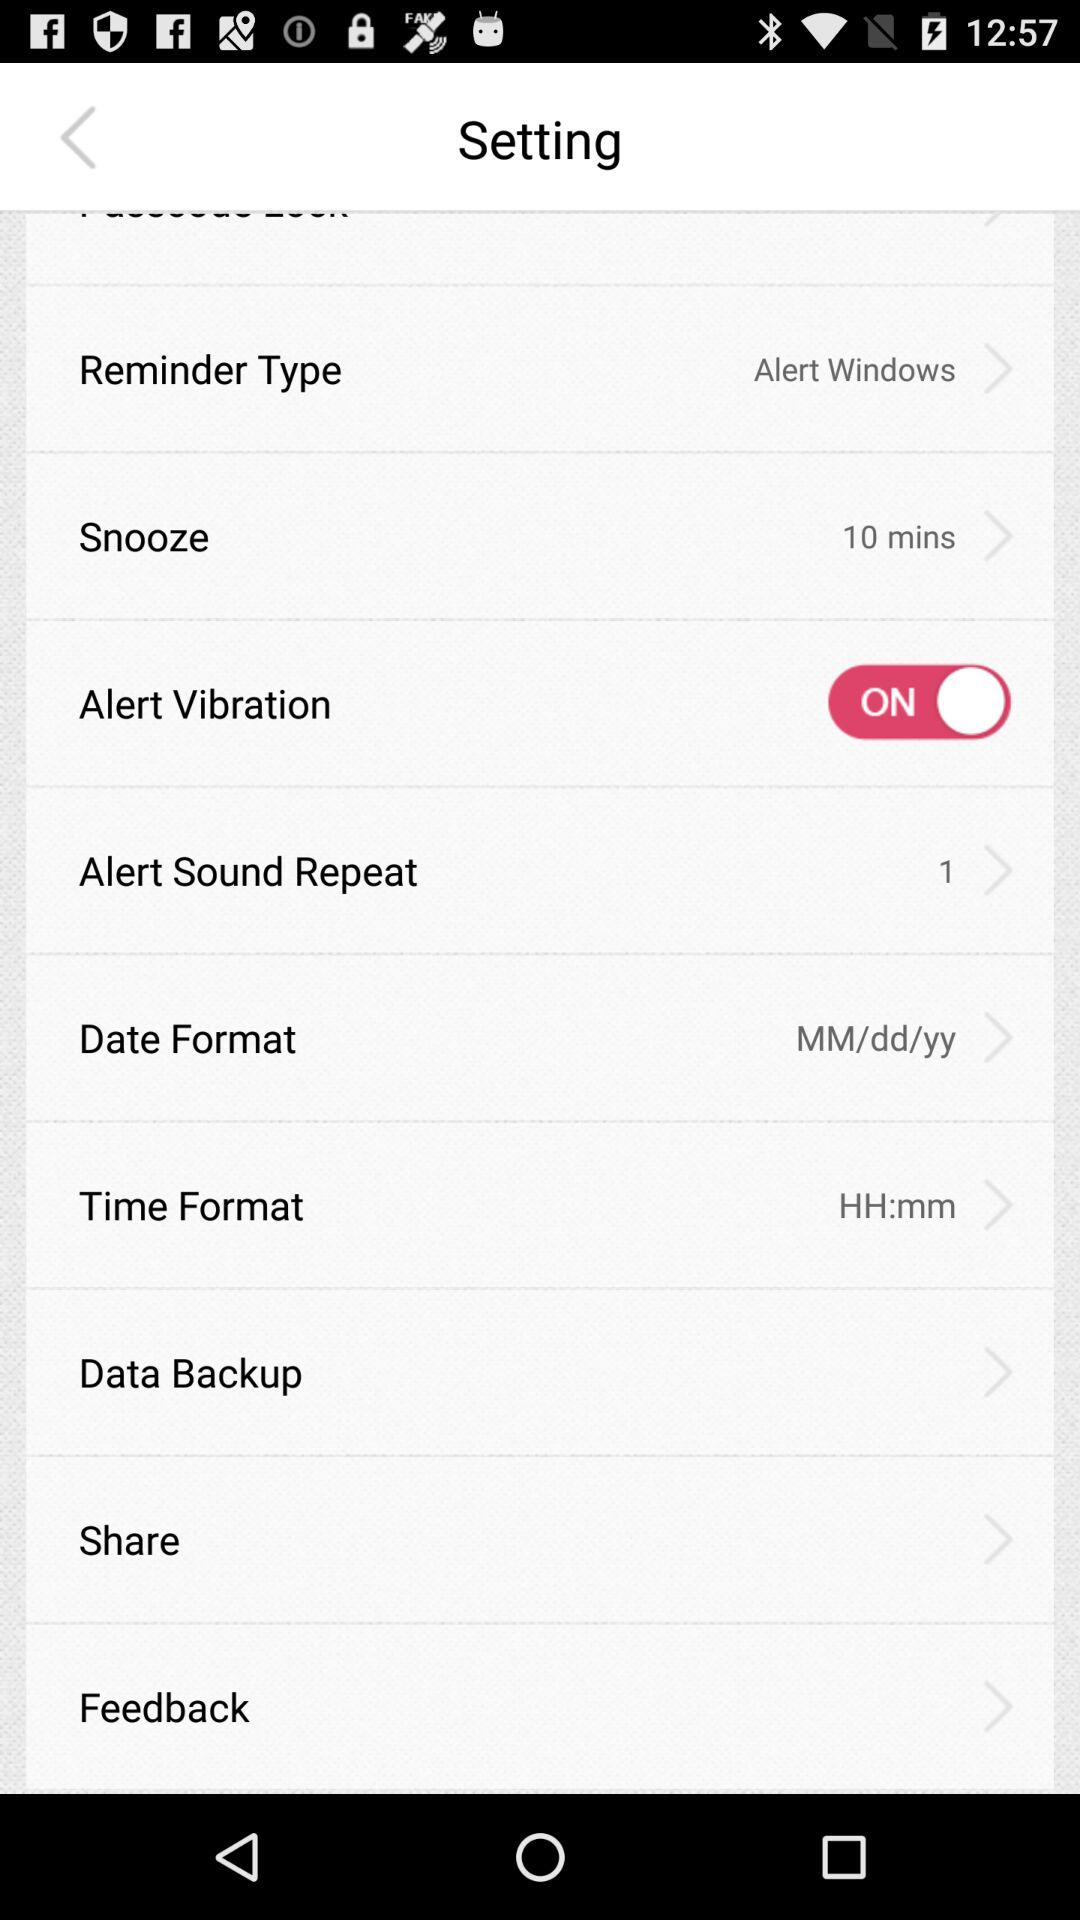What is the status of the alert vibration? The status is on. 